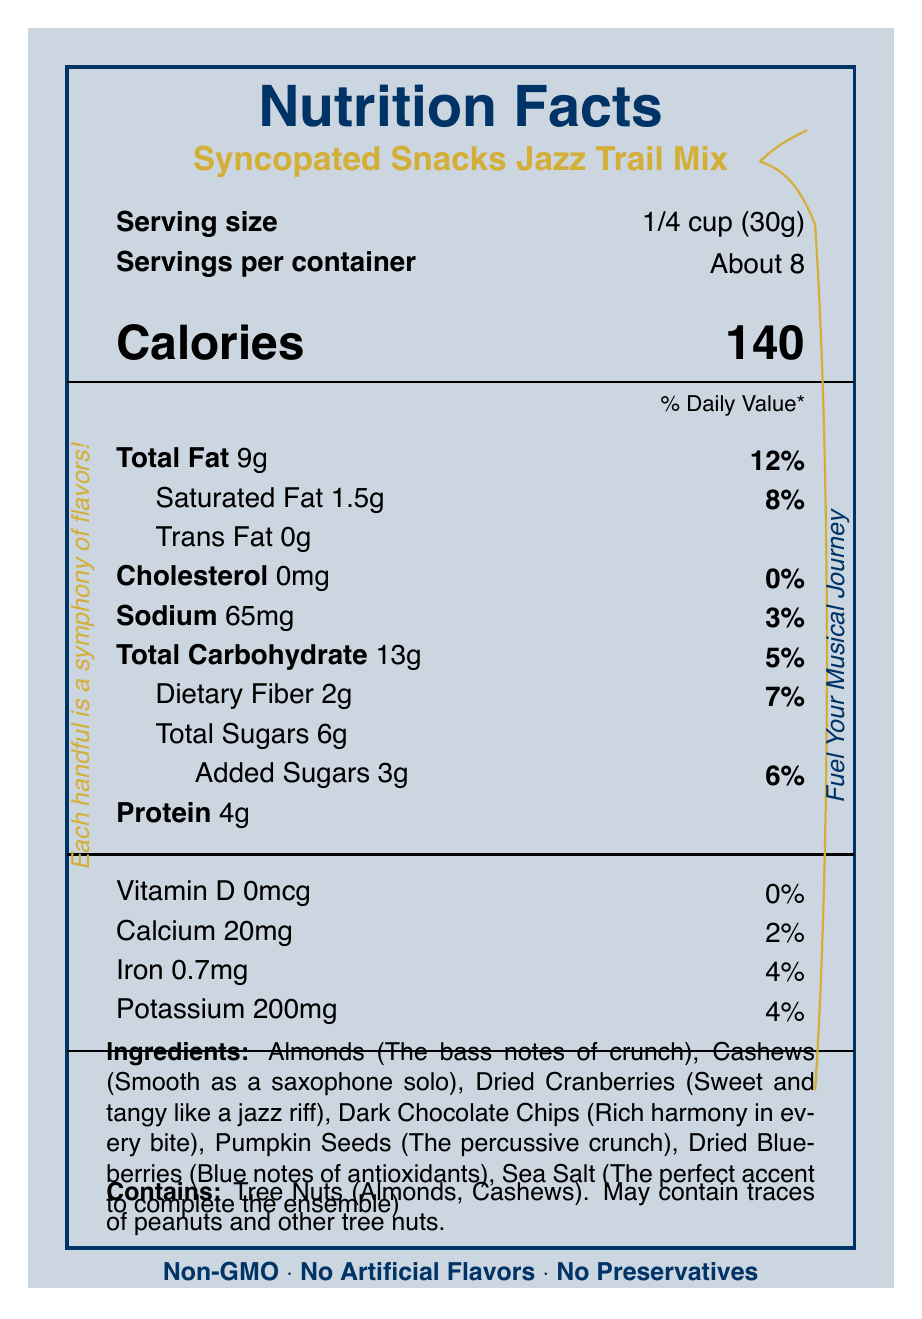what is the serving size? The serving size is directly listed as "1/4 cup (30g)" under the "Serving size" label on the document.
Answer: 1/4 cup (30g) how many servings are in the container? This information is provided right below the serving size, listed as "Servings per container: About 8."
Answer: About 8 how many calories are there per serving? The calorie information is prominently displayed below the serving size and servings per container, listed as "Calories: 140."
Answer: 140 what is the amount of total fat per serving? The total fat is listed right below the daily value note, stated as "Total Fat 9g."
Answer: 9g how much iron is in one serving? The iron content is listed in the vitamin and mineral section as "Iron 0.7mg."
Answer: 0.7mg how much potassium is there per serving? This is listed below the iron content under the vitamin and mineral information as "Potassium 200mg."
Answer: 200mg which ingredients are described as "Blue notes of antioxidants"? A. Almonds B. Cashews C. Dried Blueberries D. Dark Chocolate Chips Dried Blueberries are described as "Blue notes of antioxidants" in the ingredients section.
Answer: C which nutrient has the highest percentage of daily value? A. Total Fat B. Saturated Fat C. Sodium D. Dietary Fiber The total fat has a daily value of 12%, which is higher than the other listed values.
Answer: A how many grams of dietary fiber are in each serving? A. 1g B. 2g C. 3g D. 4g The dietary fiber content is listed next to "Dietary Fiber" as "2g."
Answer: B does the product contain tree nuts? The allergen information specifies "Contains: Tree Nuts (Almonds, Cashews)."
Answer: Yes are there any artificial flavors in Syncopated Snacks Jazz Trail Mix? The packaging claims include "No Artificial Flavors."
Answer: No does one serving of this trail mix contain cholesterol? The cholesterol content is listed as "0mg," which means there is no cholesterol.
Answer: No summarize the main idea of this Nutrition Facts Label. This summary captures the essence of the visual document by highlighting the product's nutritional information, serving size, ingredients, and unique selling points.
Answer: Syncopated Snacks Jazz Trail Mix is a non-GMO, no artificial flavors, and no preservatives trail mix. Each serving is 1/4 cup (30g), containing about 140 calories, 9g total fat, 13g total carbohydrates, 4g protein, and various vitamins and minerals. It includes ingredients like almonds, cashews, and dried cranberries, designed to fuel your musical journey. is this product good for people with peanut allergies? The allergen information mentions that the product "May contain traces of peanuts and other tree nuts," which means it might not be safe for individuals with peanut allergies, but specific suitability isn't conclusively provided.
Answer: Not enough information 